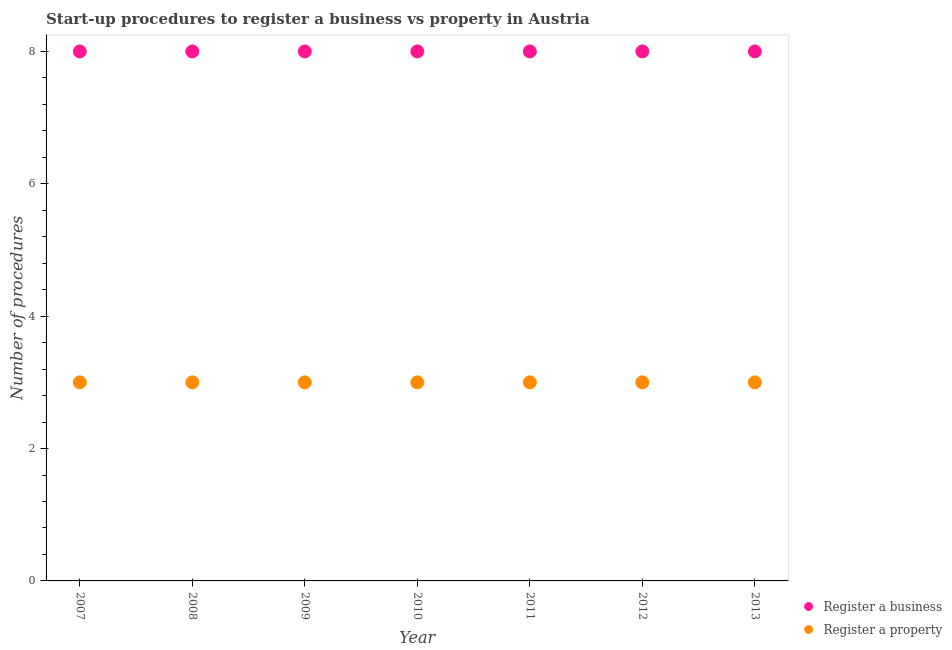What is the number of procedures to register a business in 2010?
Provide a succinct answer. 8. Across all years, what is the maximum number of procedures to register a property?
Provide a short and direct response. 3. Across all years, what is the minimum number of procedures to register a property?
Provide a succinct answer. 3. What is the total number of procedures to register a business in the graph?
Your answer should be very brief. 56. What is the difference between the number of procedures to register a business in 2010 and that in 2011?
Give a very brief answer. 0. What is the difference between the number of procedures to register a property in 2011 and the number of procedures to register a business in 2008?
Ensure brevity in your answer.  -5. What is the average number of procedures to register a property per year?
Offer a terse response. 3. In the year 2008, what is the difference between the number of procedures to register a business and number of procedures to register a property?
Your response must be concise. 5. In how many years, is the number of procedures to register a business greater than 4?
Your answer should be very brief. 7. What is the ratio of the number of procedures to register a business in 2011 to that in 2013?
Make the answer very short. 1. Is the number of procedures to register a business in 2009 less than that in 2010?
Make the answer very short. No. Is the difference between the number of procedures to register a property in 2009 and 2010 greater than the difference between the number of procedures to register a business in 2009 and 2010?
Keep it short and to the point. No. What is the difference between the highest and the lowest number of procedures to register a property?
Give a very brief answer. 0. Does the number of procedures to register a business monotonically increase over the years?
Your response must be concise. No. Is the number of procedures to register a business strictly greater than the number of procedures to register a property over the years?
Provide a succinct answer. Yes. How many dotlines are there?
Offer a very short reply. 2. What is the difference between two consecutive major ticks on the Y-axis?
Make the answer very short. 2. Does the graph contain any zero values?
Offer a terse response. No. Does the graph contain grids?
Offer a very short reply. No. What is the title of the graph?
Your response must be concise. Start-up procedures to register a business vs property in Austria. Does "Long-term debt" appear as one of the legend labels in the graph?
Your response must be concise. No. What is the label or title of the Y-axis?
Give a very brief answer. Number of procedures. What is the Number of procedures of Register a business in 2007?
Give a very brief answer. 8. What is the Number of procedures of Register a business in 2008?
Keep it short and to the point. 8. What is the Number of procedures in Register a property in 2010?
Offer a terse response. 3. What is the Number of procedures of Register a business in 2011?
Your answer should be compact. 8. What is the Number of procedures in Register a business in 2013?
Your answer should be very brief. 8. What is the Number of procedures of Register a property in 2013?
Give a very brief answer. 3. What is the total Number of procedures of Register a business in the graph?
Give a very brief answer. 56. What is the total Number of procedures of Register a property in the graph?
Give a very brief answer. 21. What is the difference between the Number of procedures in Register a business in 2007 and that in 2008?
Your answer should be compact. 0. What is the difference between the Number of procedures in Register a business in 2007 and that in 2009?
Your answer should be compact. 0. What is the difference between the Number of procedures in Register a property in 2007 and that in 2009?
Make the answer very short. 0. What is the difference between the Number of procedures of Register a property in 2007 and that in 2010?
Your answer should be very brief. 0. What is the difference between the Number of procedures of Register a business in 2007 and that in 2011?
Provide a short and direct response. 0. What is the difference between the Number of procedures of Register a business in 2007 and that in 2012?
Make the answer very short. 0. What is the difference between the Number of procedures of Register a business in 2007 and that in 2013?
Give a very brief answer. 0. What is the difference between the Number of procedures in Register a property in 2007 and that in 2013?
Provide a succinct answer. 0. What is the difference between the Number of procedures in Register a business in 2008 and that in 2009?
Give a very brief answer. 0. What is the difference between the Number of procedures of Register a property in 2008 and that in 2009?
Give a very brief answer. 0. What is the difference between the Number of procedures of Register a property in 2008 and that in 2010?
Offer a very short reply. 0. What is the difference between the Number of procedures of Register a property in 2008 and that in 2011?
Offer a terse response. 0. What is the difference between the Number of procedures in Register a property in 2008 and that in 2012?
Your response must be concise. 0. What is the difference between the Number of procedures of Register a business in 2009 and that in 2010?
Keep it short and to the point. 0. What is the difference between the Number of procedures in Register a property in 2009 and that in 2010?
Offer a terse response. 0. What is the difference between the Number of procedures in Register a business in 2009 and that in 2011?
Offer a terse response. 0. What is the difference between the Number of procedures of Register a business in 2009 and that in 2013?
Make the answer very short. 0. What is the difference between the Number of procedures of Register a property in 2009 and that in 2013?
Offer a very short reply. 0. What is the difference between the Number of procedures in Register a business in 2010 and that in 2012?
Offer a very short reply. 0. What is the difference between the Number of procedures of Register a property in 2010 and that in 2012?
Provide a succinct answer. 0. What is the difference between the Number of procedures in Register a property in 2010 and that in 2013?
Provide a short and direct response. 0. What is the difference between the Number of procedures in Register a property in 2011 and that in 2012?
Ensure brevity in your answer.  0. What is the difference between the Number of procedures of Register a business in 2011 and that in 2013?
Make the answer very short. 0. What is the difference between the Number of procedures of Register a business in 2007 and the Number of procedures of Register a property in 2011?
Your answer should be very brief. 5. What is the difference between the Number of procedures of Register a business in 2007 and the Number of procedures of Register a property in 2013?
Offer a terse response. 5. What is the difference between the Number of procedures in Register a business in 2008 and the Number of procedures in Register a property in 2009?
Keep it short and to the point. 5. What is the difference between the Number of procedures in Register a business in 2008 and the Number of procedures in Register a property in 2012?
Offer a terse response. 5. What is the difference between the Number of procedures in Register a business in 2009 and the Number of procedures in Register a property in 2010?
Make the answer very short. 5. What is the difference between the Number of procedures of Register a business in 2011 and the Number of procedures of Register a property in 2012?
Ensure brevity in your answer.  5. What is the difference between the Number of procedures in Register a business in 2012 and the Number of procedures in Register a property in 2013?
Keep it short and to the point. 5. What is the average Number of procedures in Register a business per year?
Provide a short and direct response. 8. In the year 2007, what is the difference between the Number of procedures in Register a business and Number of procedures in Register a property?
Your response must be concise. 5. In the year 2011, what is the difference between the Number of procedures in Register a business and Number of procedures in Register a property?
Provide a short and direct response. 5. What is the ratio of the Number of procedures of Register a property in 2007 to that in 2008?
Offer a terse response. 1. What is the ratio of the Number of procedures of Register a business in 2007 to that in 2009?
Provide a succinct answer. 1. What is the ratio of the Number of procedures in Register a property in 2007 to that in 2012?
Provide a short and direct response. 1. What is the ratio of the Number of procedures in Register a business in 2007 to that in 2013?
Your answer should be compact. 1. What is the ratio of the Number of procedures of Register a property in 2007 to that in 2013?
Your answer should be very brief. 1. What is the ratio of the Number of procedures of Register a business in 2008 to that in 2009?
Offer a very short reply. 1. What is the ratio of the Number of procedures of Register a business in 2008 to that in 2010?
Your response must be concise. 1. What is the ratio of the Number of procedures in Register a property in 2008 to that in 2010?
Offer a very short reply. 1. What is the ratio of the Number of procedures of Register a business in 2008 to that in 2013?
Your answer should be very brief. 1. What is the ratio of the Number of procedures of Register a business in 2009 to that in 2010?
Ensure brevity in your answer.  1. What is the ratio of the Number of procedures of Register a business in 2009 to that in 2011?
Offer a very short reply. 1. What is the ratio of the Number of procedures of Register a business in 2009 to that in 2013?
Ensure brevity in your answer.  1. What is the ratio of the Number of procedures of Register a business in 2010 to that in 2011?
Provide a short and direct response. 1. What is the ratio of the Number of procedures in Register a property in 2010 to that in 2013?
Your answer should be very brief. 1. What is the ratio of the Number of procedures in Register a property in 2011 to that in 2012?
Provide a short and direct response. 1. What is the ratio of the Number of procedures in Register a property in 2011 to that in 2013?
Keep it short and to the point. 1. What is the ratio of the Number of procedures in Register a business in 2012 to that in 2013?
Your answer should be compact. 1. What is the ratio of the Number of procedures in Register a property in 2012 to that in 2013?
Provide a short and direct response. 1. What is the difference between the highest and the second highest Number of procedures of Register a business?
Offer a terse response. 0. What is the difference between the highest and the second highest Number of procedures of Register a property?
Keep it short and to the point. 0. What is the difference between the highest and the lowest Number of procedures in Register a business?
Make the answer very short. 0. What is the difference between the highest and the lowest Number of procedures of Register a property?
Your answer should be very brief. 0. 